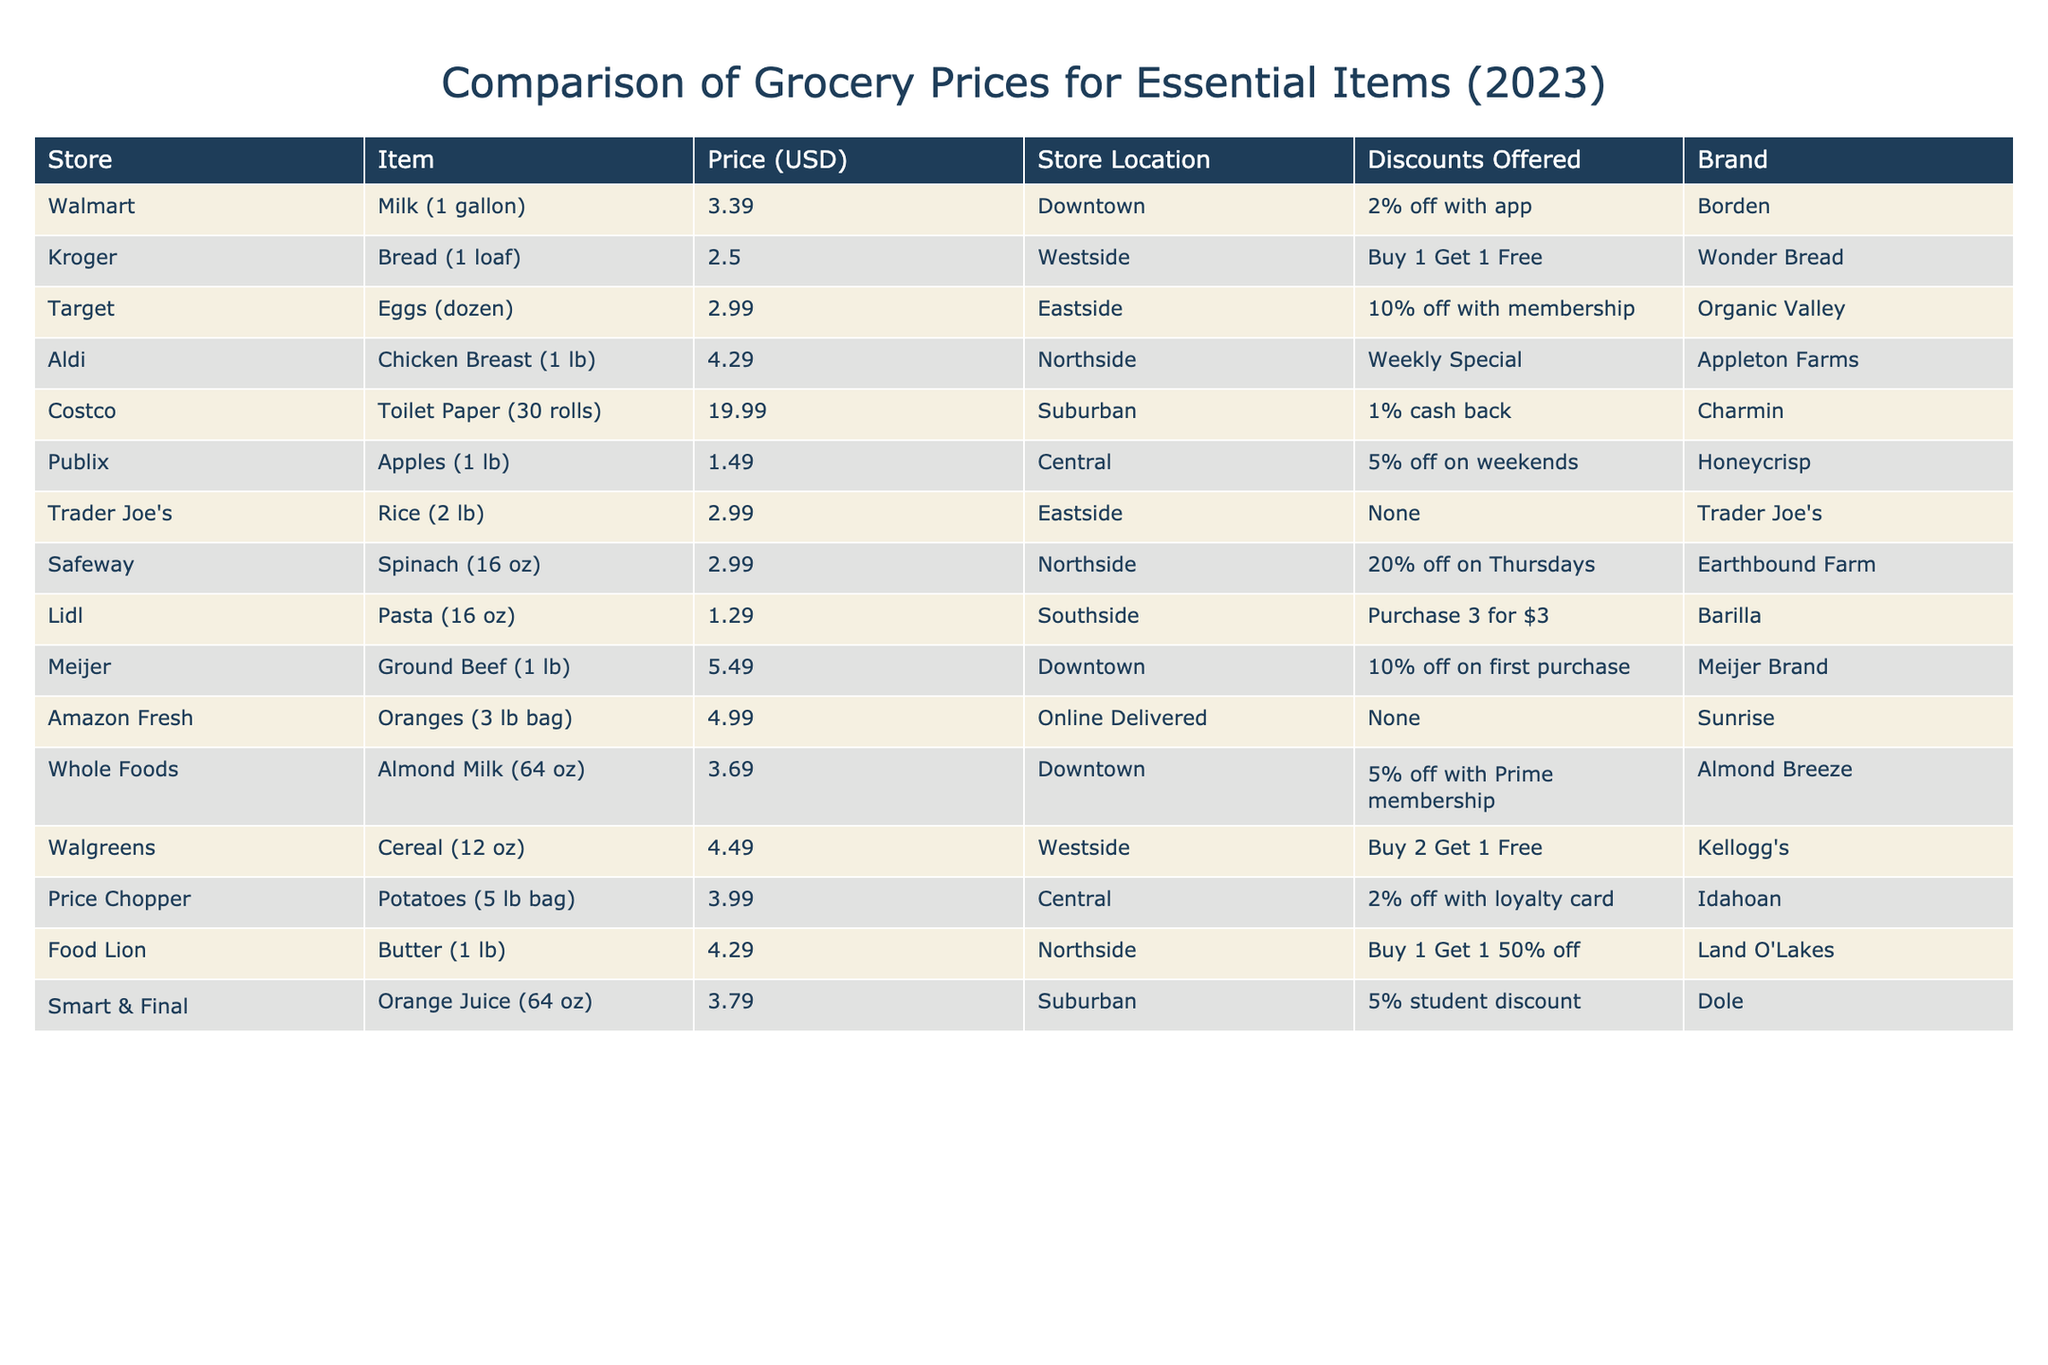What is the price of chicken breast per pound at Aldi? The table shows that the price of chicken breast at Aldi is listed as $4.29 per pound.
Answer: $4.29 Which store offers a 10% discount on eggs? The table indicates that Target offers a 10% discount on eggs with membership.
Answer: Target What is the total price of buying 3 packages of pasta at Lidl? The pasta costs $1.29 per package at Lidl, so the total for 3 packages is calculated as 3 x $1.29 = $3.87.
Answer: $3.87 Which store has the lowest price for apples? The price of apples at Publix is $1.49 per pound, which is lower than prices at other stores mentioned in the table.
Answer: Publix Is it true that Costco offers a cash back discount? According to the table, Costco offers a 1% cash back on their toilet paper. Therefore, the statement is true.
Answer: Yes What is the average price of meat items (chicken breast and ground beef)? The price of chicken breast is $4.29, and the price of ground beef is $5.49. To find the average, add these two prices: $4.29 + $5.49 = $9.78, then divide by 2, giving $9.78 / 2 = $4.89.
Answer: $4.89 Which store sells a 64 oz almond milk and what is its price? Whole Foods offers a 64 oz almond milk at a price of $3.69, as seen in the table.
Answer: Whole Foods, $3.69 If you buy butter and spinach, what will be the total cost at their respective stores? Butter costs $4.29 at Food Lion and spinach costs $2.99 at Safeway. To find the total cost, add these prices: $4.29 + $2.99 = $7.28.
Answer: $7.28 Is the price of toilet paper at Costco higher than $20? The table shows that toilet paper at Costco costs $19.99, which is not higher than $20. Therefore, the statement is false.
Answer: No Which store is located in the Eastside and what is the price of items sold there? Target and Trader Joe’s are both located in the Eastside. Target sells eggs for $2.99, and Trader Joe’s sells rice for $2.99.
Answer: Target: $2.99; Trader Joe's: $2.99 